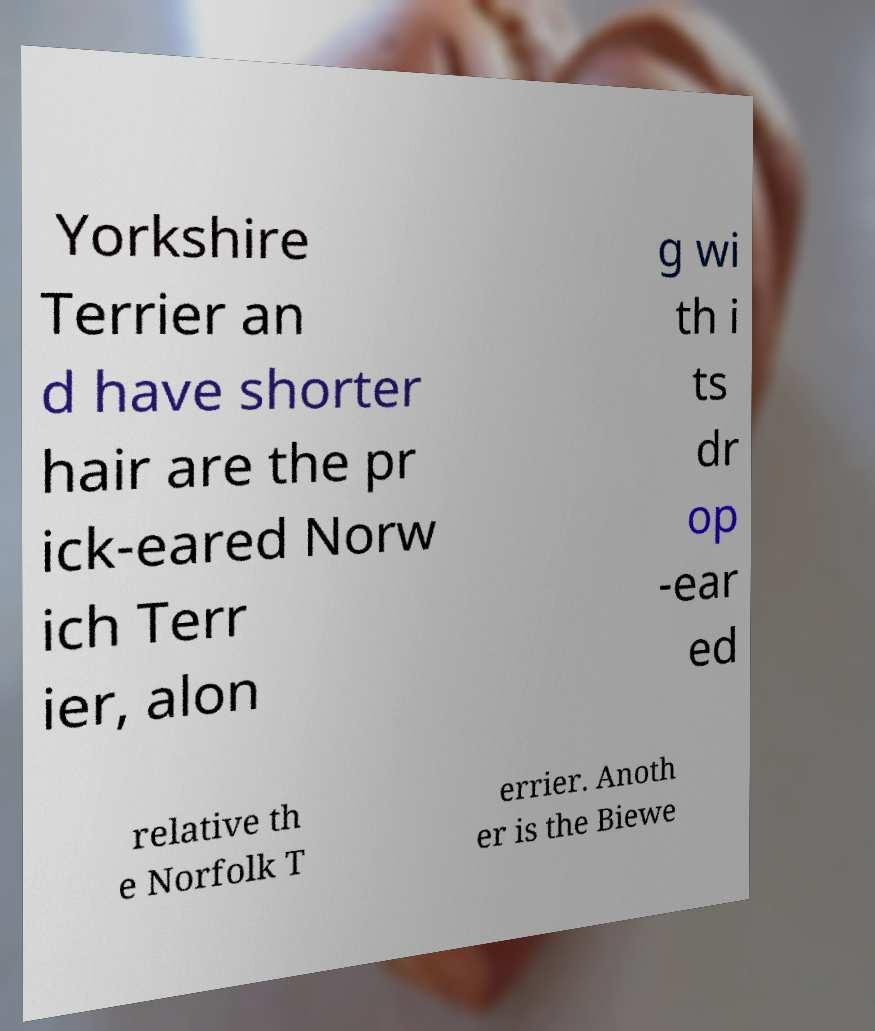Can you read and provide the text displayed in the image?This photo seems to have some interesting text. Can you extract and type it out for me? Yorkshire Terrier an d have shorter hair are the pr ick-eared Norw ich Terr ier, alon g wi th i ts dr op -ear ed relative th e Norfolk T errier. Anoth er is the Biewe 